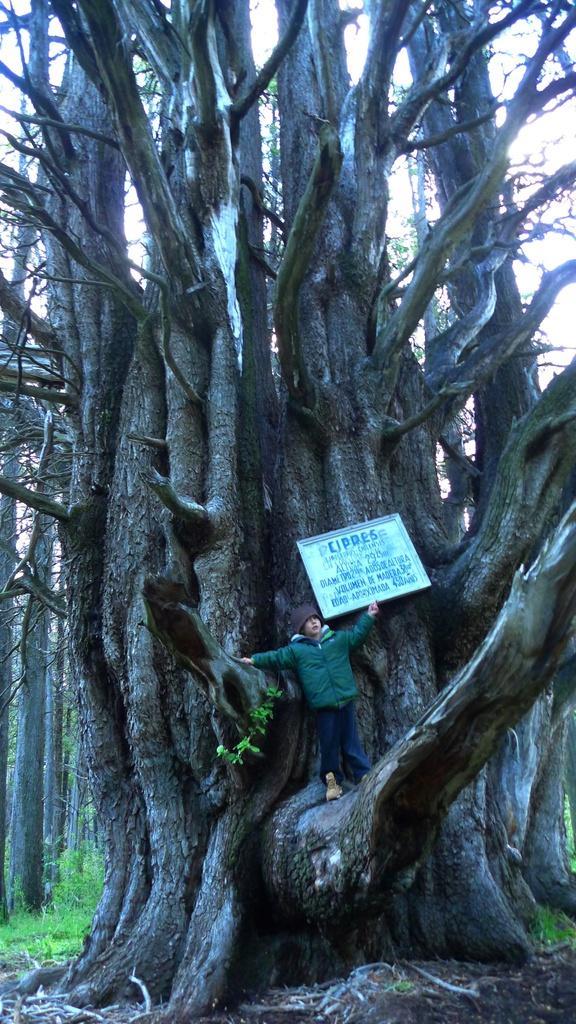Can you describe this image briefly? In this image I can see tree and a boy is wearing jacket, cap on the head, holding a board in the hand and standing on a trunk. In the background also there are many trees and also I can see the grass. 